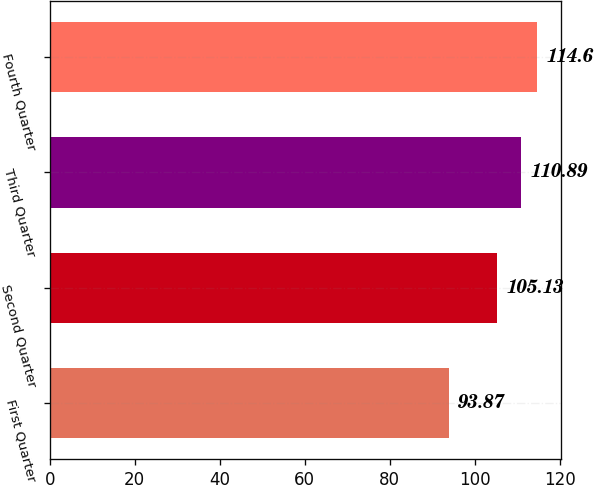<chart> <loc_0><loc_0><loc_500><loc_500><bar_chart><fcel>First Quarter<fcel>Second Quarter<fcel>Third Quarter<fcel>Fourth Quarter<nl><fcel>93.87<fcel>105.13<fcel>110.89<fcel>114.6<nl></chart> 